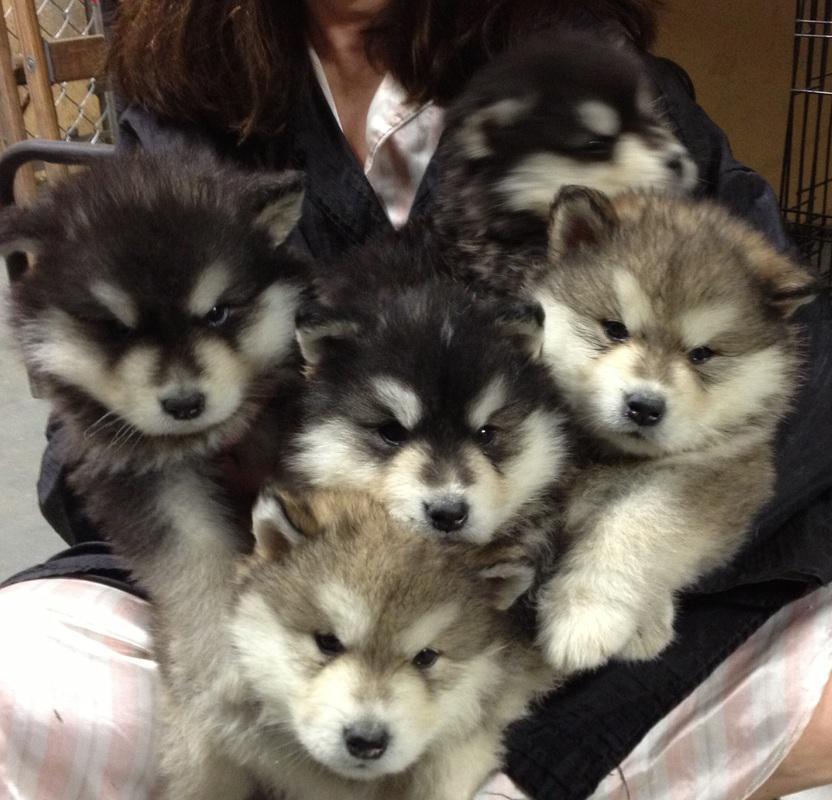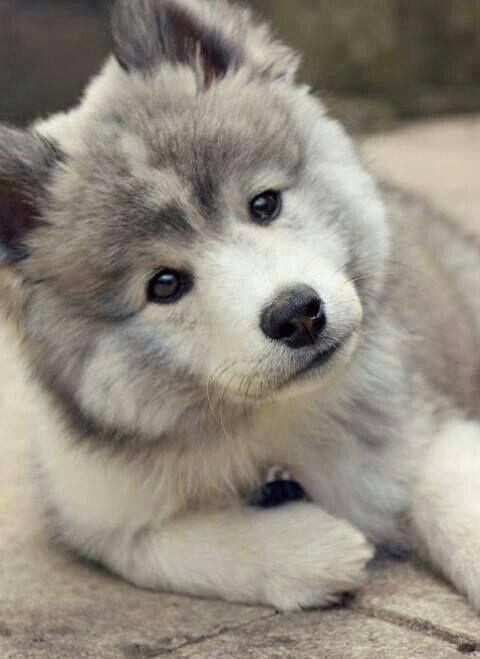The first image is the image on the left, the second image is the image on the right. Considering the images on both sides, is "The left and right image contains a total of six dogs." valid? Answer yes or no. Yes. The first image is the image on the left, the second image is the image on the right. For the images displayed, is the sentence "The left image contains five forward-facing husky puppies in two different coat color combinations." factually correct? Answer yes or no. Yes. 